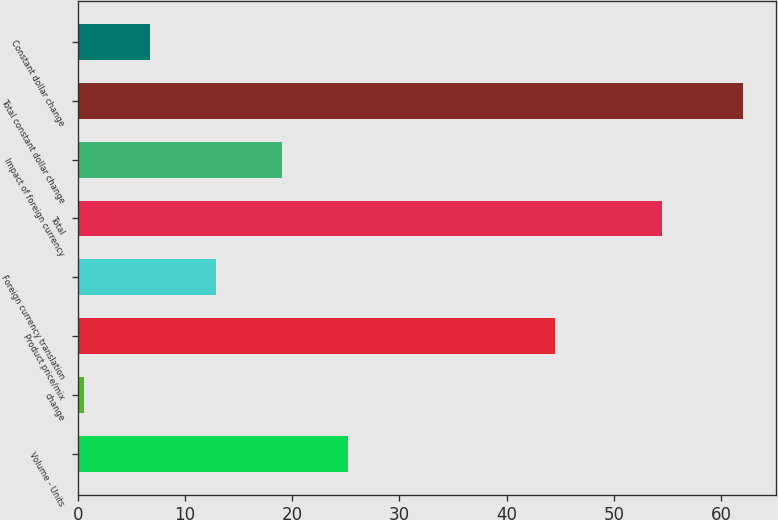Convert chart. <chart><loc_0><loc_0><loc_500><loc_500><bar_chart><fcel>Volume - Units<fcel>change<fcel>Product price/mix<fcel>Foreign currency translation<fcel>Total<fcel>Impact of foreign currency<fcel>Total constant dollar change<fcel>Constant dollar change<nl><fcel>25.16<fcel>0.6<fcel>44.5<fcel>12.88<fcel>54.5<fcel>19.02<fcel>62<fcel>6.74<nl></chart> 